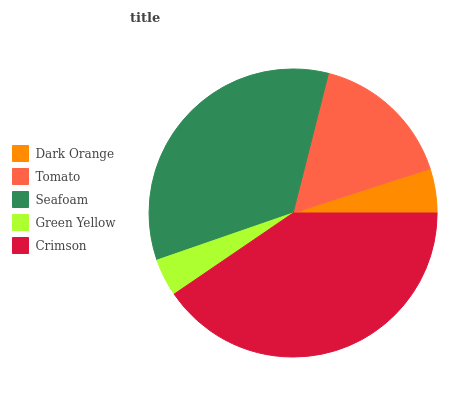Is Green Yellow the minimum?
Answer yes or no. Yes. Is Crimson the maximum?
Answer yes or no. Yes. Is Tomato the minimum?
Answer yes or no. No. Is Tomato the maximum?
Answer yes or no. No. Is Tomato greater than Dark Orange?
Answer yes or no. Yes. Is Dark Orange less than Tomato?
Answer yes or no. Yes. Is Dark Orange greater than Tomato?
Answer yes or no. No. Is Tomato less than Dark Orange?
Answer yes or no. No. Is Tomato the high median?
Answer yes or no. Yes. Is Tomato the low median?
Answer yes or no. Yes. Is Green Yellow the high median?
Answer yes or no. No. Is Seafoam the low median?
Answer yes or no. No. 